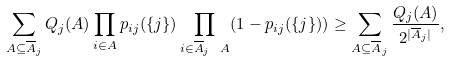<formula> <loc_0><loc_0><loc_500><loc_500>\sum _ { A \subseteq \overline { A } _ { j } } Q _ { j } ( A ) \prod _ { i \in A } p _ { i j } ( \{ j \} ) \prod _ { i \in \overline { A } _ { j } \ A } ( 1 - p _ { i j } ( \{ j \} ) ) \geq \sum _ { A \subseteq \overline { A } _ { j } } \frac { Q _ { j } ( A ) } { 2 ^ { | \overline { A } _ { j } | } } ,</formula> 